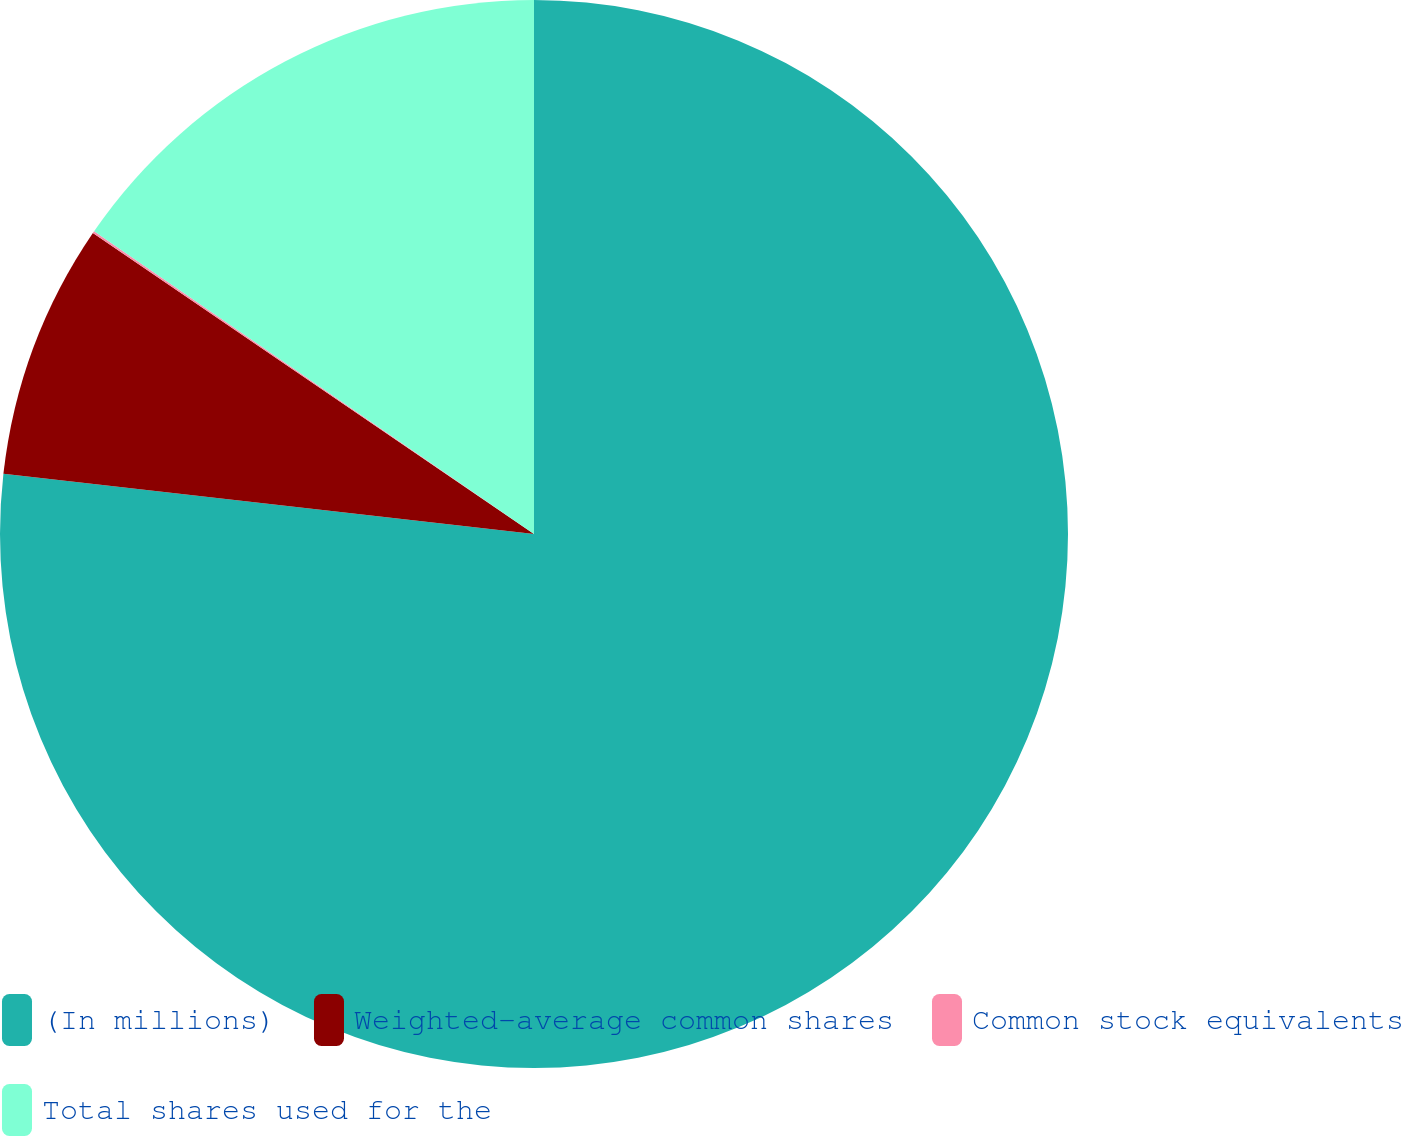<chart> <loc_0><loc_0><loc_500><loc_500><pie_chart><fcel>(In millions)<fcel>Weighted-average common shares<fcel>Common stock equivalents<fcel>Total shares used for the<nl><fcel>76.8%<fcel>7.73%<fcel>0.06%<fcel>15.41%<nl></chart> 